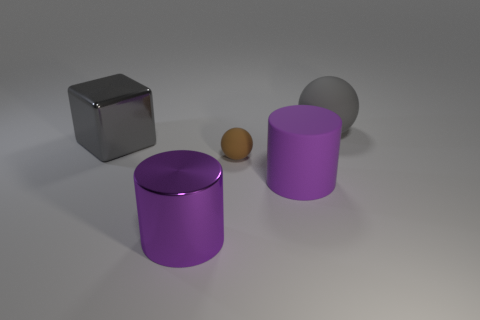How many things are either matte spheres that are to the left of the big gray rubber object or large purple cylinders in front of the tiny rubber thing?
Give a very brief answer. 3. Do the gray ball and the purple rubber cylinder have the same size?
Your answer should be very brief. Yes. Are there more big things than cubes?
Your answer should be compact. Yes. What number of other things are there of the same color as the tiny sphere?
Your response must be concise. 0. How many things are either purple cylinders or matte balls?
Ensure brevity in your answer.  4. There is a metallic thing in front of the block; is it the same shape as the gray matte thing?
Your response must be concise. No. There is a matte ball to the left of the big rubber thing to the left of the big gray rubber sphere; what is its color?
Your answer should be very brief. Brown. Are there fewer large cyan matte things than gray blocks?
Give a very brief answer. Yes. Are there any brown things that have the same material as the big gray ball?
Offer a very short reply. Yes. There is a purple shiny object; is its shape the same as the large gray thing in front of the large gray sphere?
Offer a terse response. No. 